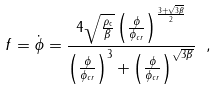<formula> <loc_0><loc_0><loc_500><loc_500>f = \dot { \phi } = \frac { 4 \sqrt { \frac { \rho _ { \text {c} } } { \beta } } \left ( \frac { \phi } { \phi _ { c r } } \right ) ^ { \frac { 3 + \sqrt { 3 \beta } } { 2 } } } { \left ( \frac { \phi } { \phi _ { c r } } \right ) ^ { 3 } + \left ( \frac { \phi } { \phi _ { c r } } \right ) ^ { \sqrt { 3 \beta } } } \ ,</formula> 